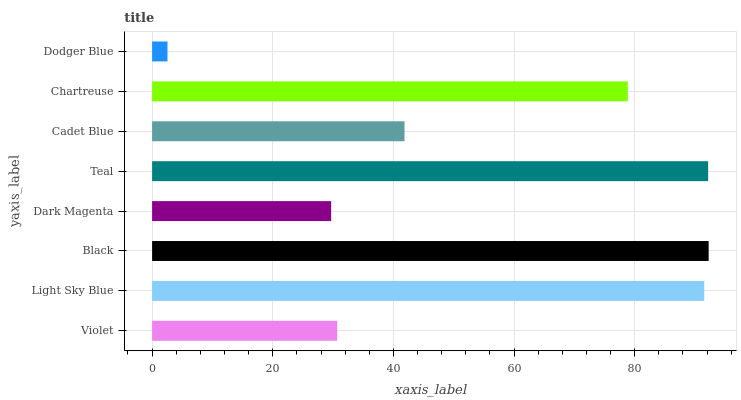Is Dodger Blue the minimum?
Answer yes or no. Yes. Is Black the maximum?
Answer yes or no. Yes. Is Light Sky Blue the minimum?
Answer yes or no. No. Is Light Sky Blue the maximum?
Answer yes or no. No. Is Light Sky Blue greater than Violet?
Answer yes or no. Yes. Is Violet less than Light Sky Blue?
Answer yes or no. Yes. Is Violet greater than Light Sky Blue?
Answer yes or no. No. Is Light Sky Blue less than Violet?
Answer yes or no. No. Is Chartreuse the high median?
Answer yes or no. Yes. Is Cadet Blue the low median?
Answer yes or no. Yes. Is Dark Magenta the high median?
Answer yes or no. No. Is Black the low median?
Answer yes or no. No. 